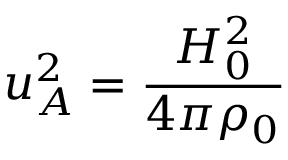Convert formula to latex. <formula><loc_0><loc_0><loc_500><loc_500>u _ { A } ^ { 2 } = \frac { H _ { 0 } ^ { 2 } } { 4 \pi \rho _ { 0 } }</formula> 